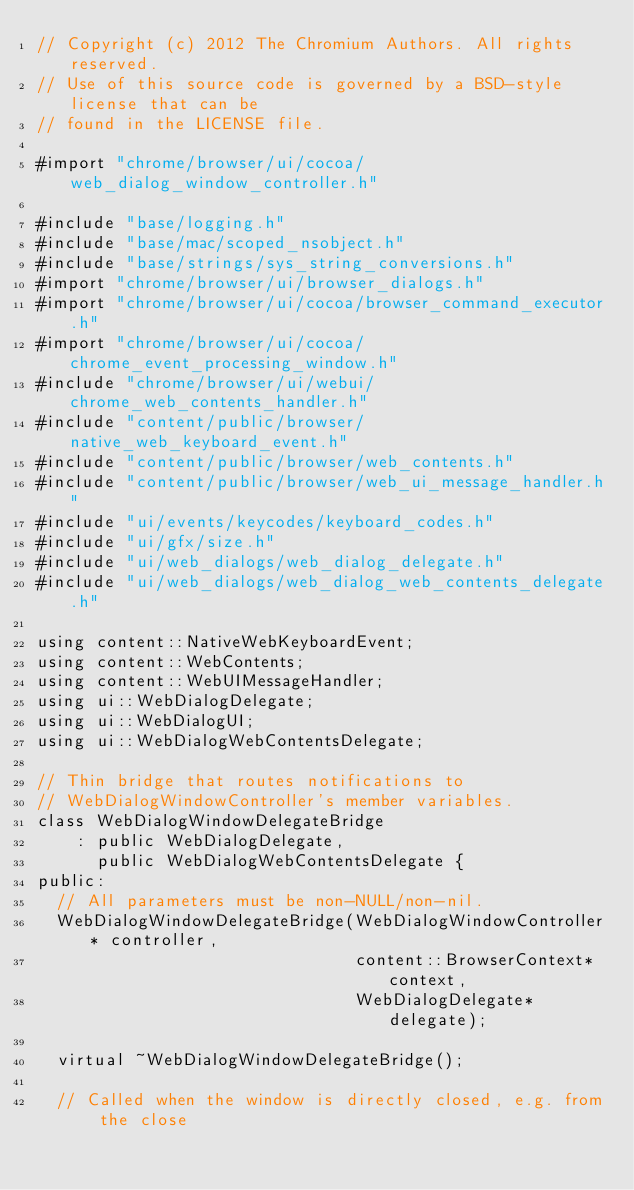<code> <loc_0><loc_0><loc_500><loc_500><_ObjectiveC_>// Copyright (c) 2012 The Chromium Authors. All rights reserved.
// Use of this source code is governed by a BSD-style license that can be
// found in the LICENSE file.

#import "chrome/browser/ui/cocoa/web_dialog_window_controller.h"

#include "base/logging.h"
#include "base/mac/scoped_nsobject.h"
#include "base/strings/sys_string_conversions.h"
#import "chrome/browser/ui/browser_dialogs.h"
#import "chrome/browser/ui/cocoa/browser_command_executor.h"
#import "chrome/browser/ui/cocoa/chrome_event_processing_window.h"
#include "chrome/browser/ui/webui/chrome_web_contents_handler.h"
#include "content/public/browser/native_web_keyboard_event.h"
#include "content/public/browser/web_contents.h"
#include "content/public/browser/web_ui_message_handler.h"
#include "ui/events/keycodes/keyboard_codes.h"
#include "ui/gfx/size.h"
#include "ui/web_dialogs/web_dialog_delegate.h"
#include "ui/web_dialogs/web_dialog_web_contents_delegate.h"

using content::NativeWebKeyboardEvent;
using content::WebContents;
using content::WebUIMessageHandler;
using ui::WebDialogDelegate;
using ui::WebDialogUI;
using ui::WebDialogWebContentsDelegate;

// Thin bridge that routes notifications to
// WebDialogWindowController's member variables.
class WebDialogWindowDelegateBridge
    : public WebDialogDelegate,
      public WebDialogWebContentsDelegate {
public:
  // All parameters must be non-NULL/non-nil.
  WebDialogWindowDelegateBridge(WebDialogWindowController* controller,
                                content::BrowserContext* context,
                                WebDialogDelegate* delegate);

  virtual ~WebDialogWindowDelegateBridge();

  // Called when the window is directly closed, e.g. from the close</code> 